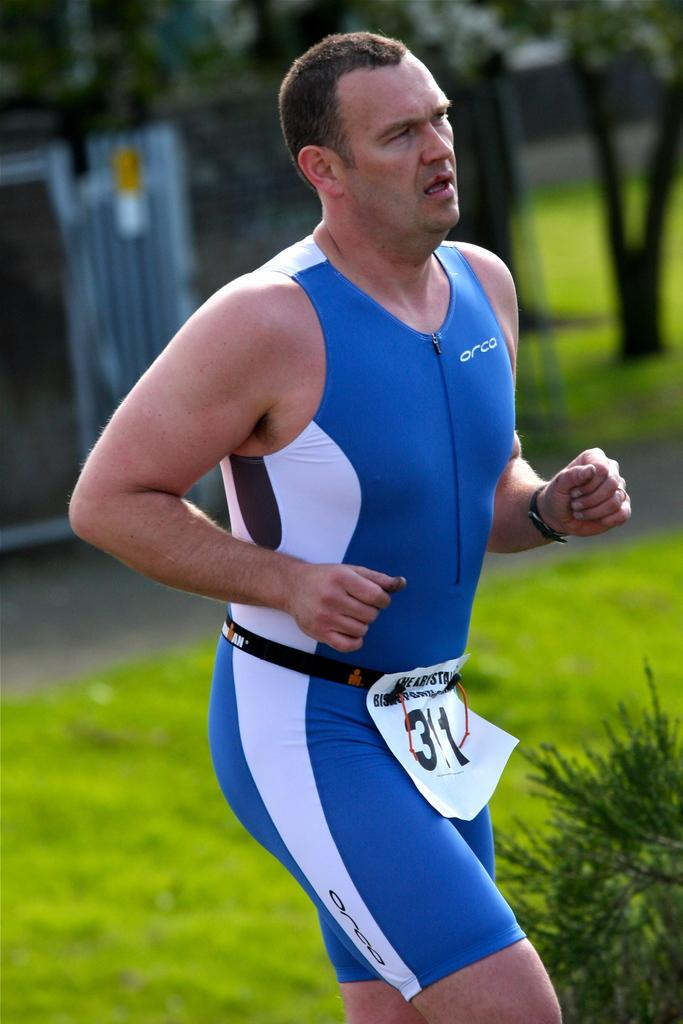<image>
Relay a brief, clear account of the picture shown. A man is running in his runners outfit with the name orca on it. 